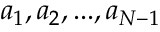Convert formula to latex. <formula><loc_0><loc_0><loc_500><loc_500>a _ { 1 } , a _ { 2 } , \dots , a _ { N - 1 }</formula> 